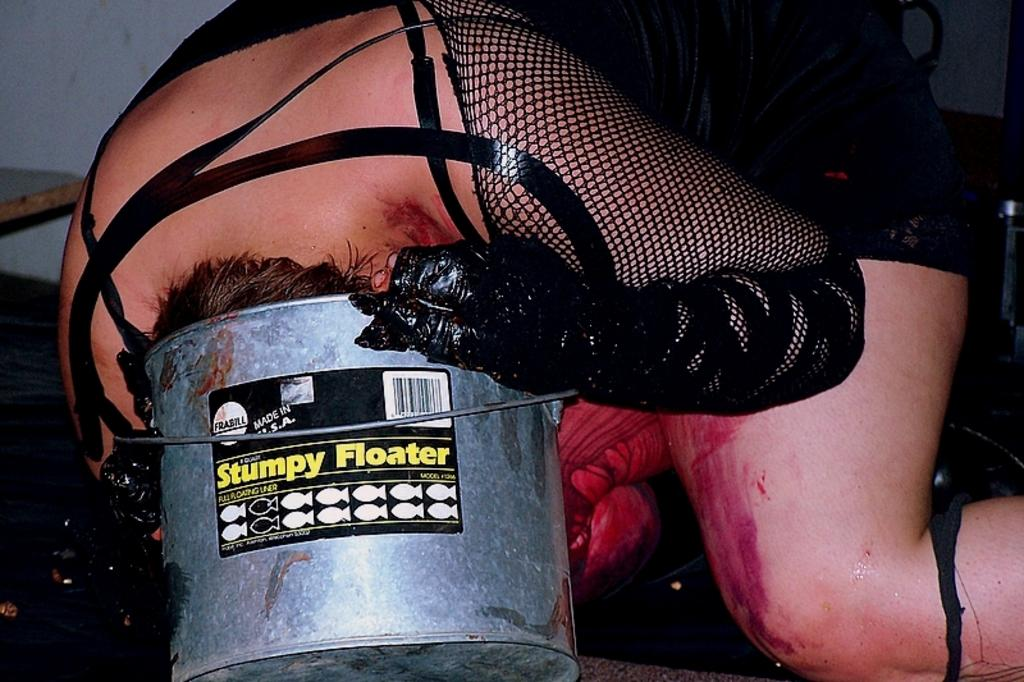What is the person in the image doing? The person is putting their head into a bucket. What is the person wearing in the image? The person is wearing a black dress. Is there anything attached to the bucket? Yes, there is a sticker attached to the bucket. How many houses can be seen through the fog in the image? There is no fog or houses present in the image; it features a person putting their head into a bucket. 